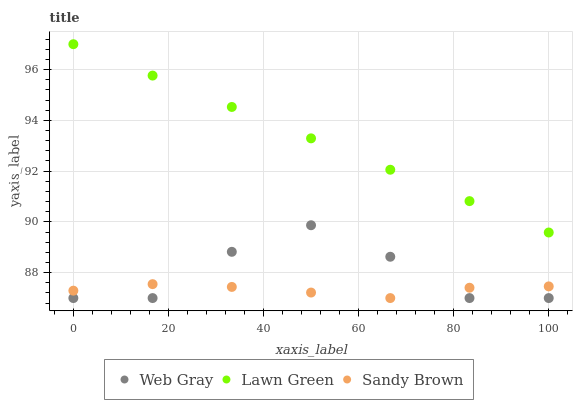Does Sandy Brown have the minimum area under the curve?
Answer yes or no. Yes. Does Lawn Green have the maximum area under the curve?
Answer yes or no. Yes. Does Web Gray have the minimum area under the curve?
Answer yes or no. No. Does Web Gray have the maximum area under the curve?
Answer yes or no. No. Is Lawn Green the smoothest?
Answer yes or no. Yes. Is Web Gray the roughest?
Answer yes or no. Yes. Is Sandy Brown the smoothest?
Answer yes or no. No. Is Sandy Brown the roughest?
Answer yes or no. No. Does Web Gray have the lowest value?
Answer yes or no. Yes. Does Lawn Green have the highest value?
Answer yes or no. Yes. Does Web Gray have the highest value?
Answer yes or no. No. Is Sandy Brown less than Lawn Green?
Answer yes or no. Yes. Is Lawn Green greater than Sandy Brown?
Answer yes or no. Yes. Does Sandy Brown intersect Web Gray?
Answer yes or no. Yes. Is Sandy Brown less than Web Gray?
Answer yes or no. No. Is Sandy Brown greater than Web Gray?
Answer yes or no. No. Does Sandy Brown intersect Lawn Green?
Answer yes or no. No. 